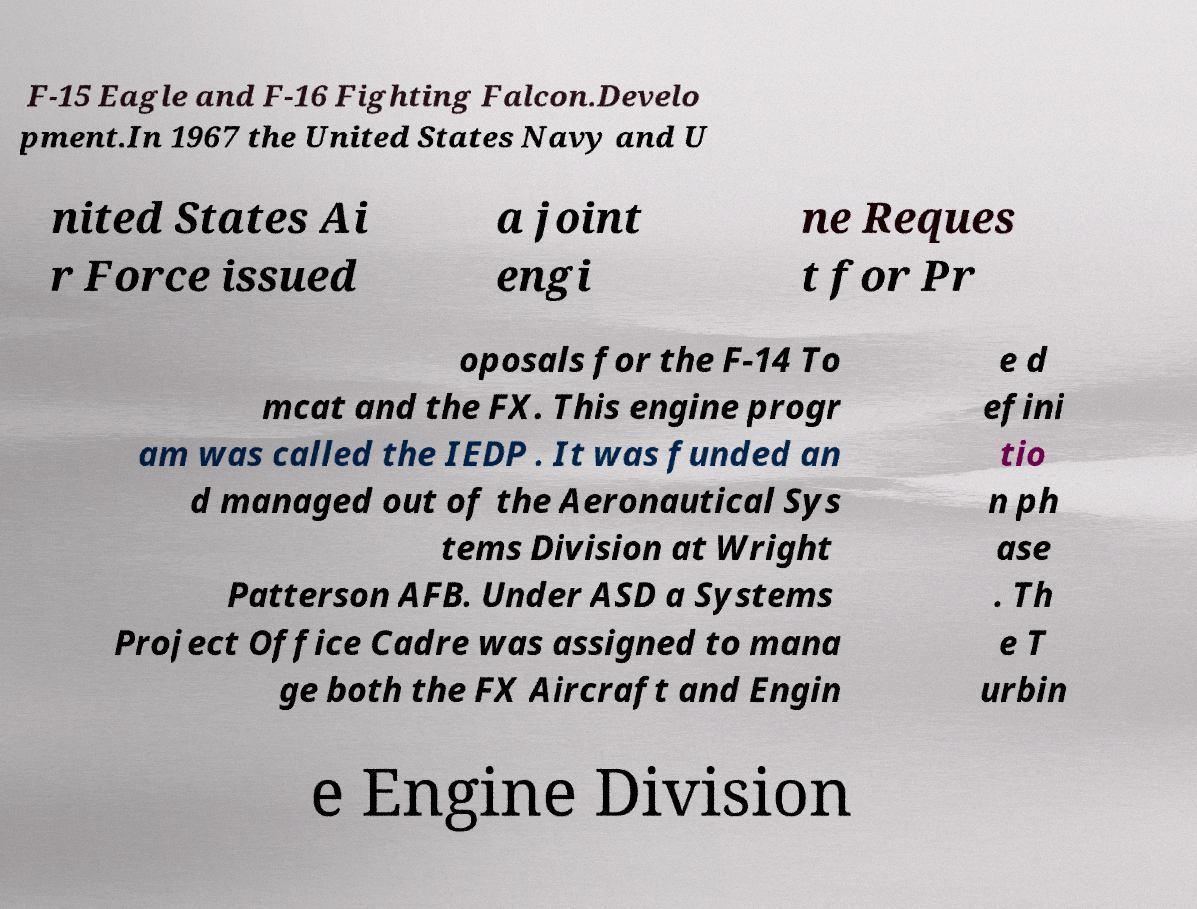I need the written content from this picture converted into text. Can you do that? F-15 Eagle and F-16 Fighting Falcon.Develo pment.In 1967 the United States Navy and U nited States Ai r Force issued a joint engi ne Reques t for Pr oposals for the F-14 To mcat and the FX. This engine progr am was called the IEDP . It was funded an d managed out of the Aeronautical Sys tems Division at Wright Patterson AFB. Under ASD a Systems Project Office Cadre was assigned to mana ge both the FX Aircraft and Engin e d efini tio n ph ase . Th e T urbin e Engine Division 